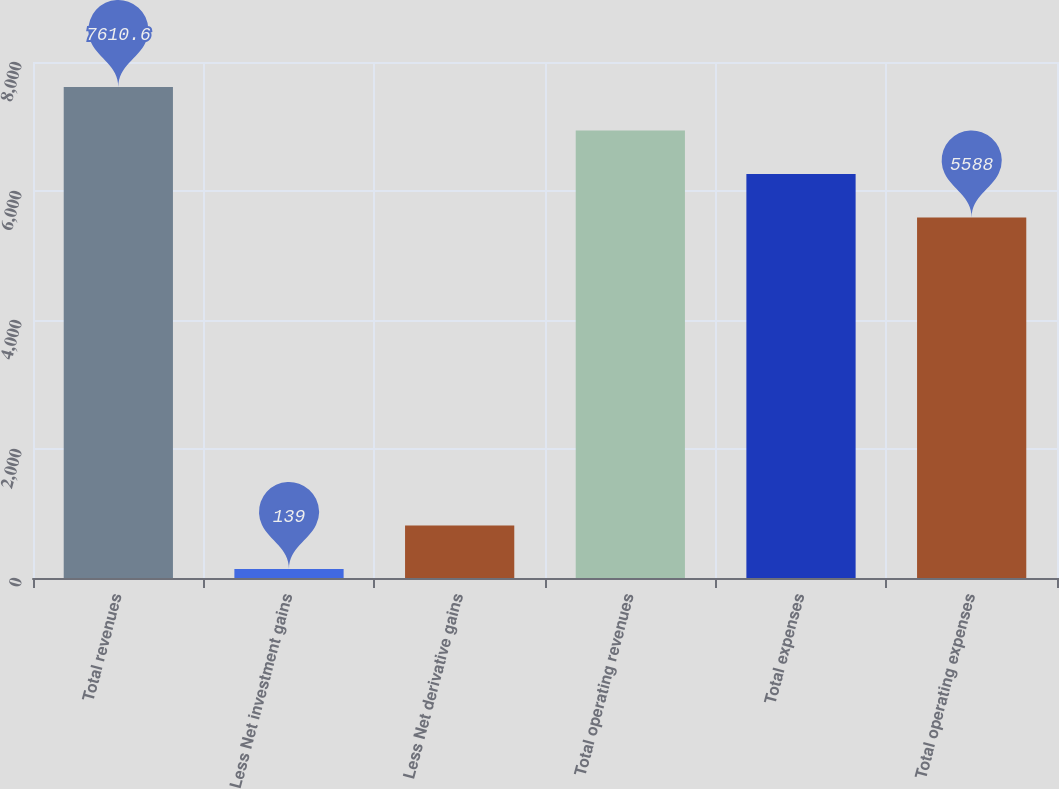<chart> <loc_0><loc_0><loc_500><loc_500><bar_chart><fcel>Total revenues<fcel>Less Net investment gains<fcel>Less Net derivative gains<fcel>Total operating revenues<fcel>Total expenses<fcel>Total operating expenses<nl><fcel>7610.6<fcel>139<fcel>813.2<fcel>6936.4<fcel>6262.2<fcel>5588<nl></chart> 